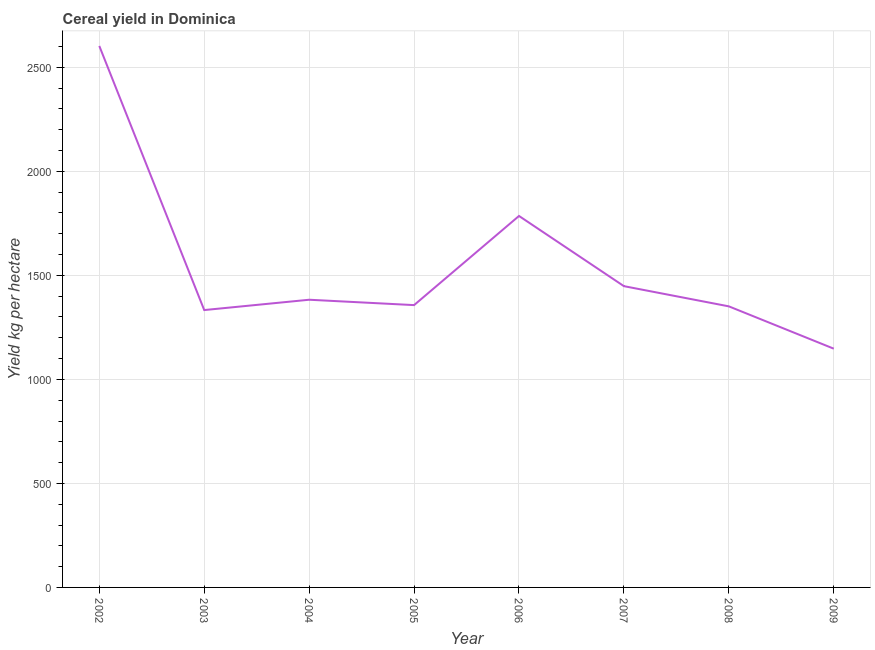What is the cereal yield in 2006?
Your answer should be compact. 1785.71. Across all years, what is the maximum cereal yield?
Ensure brevity in your answer.  2602.94. Across all years, what is the minimum cereal yield?
Keep it short and to the point. 1147.73. In which year was the cereal yield maximum?
Make the answer very short. 2002. In which year was the cereal yield minimum?
Make the answer very short. 2009. What is the sum of the cereal yield?
Provide a short and direct response. 1.24e+04. What is the difference between the cereal yield in 2005 and 2008?
Keep it short and to the point. 6. What is the average cereal yield per year?
Make the answer very short. 1551.16. What is the median cereal yield?
Your answer should be very brief. 1370.06. Do a majority of the years between 2006 and 2003 (inclusive) have cereal yield greater than 1500 kg per hectare?
Provide a short and direct response. Yes. What is the ratio of the cereal yield in 2006 to that in 2009?
Your answer should be very brief. 1.56. Is the difference between the cereal yield in 2004 and 2007 greater than the difference between any two years?
Ensure brevity in your answer.  No. What is the difference between the highest and the second highest cereal yield?
Your answer should be very brief. 817.23. What is the difference between the highest and the lowest cereal yield?
Offer a very short reply. 1455.21. Does the cereal yield monotonically increase over the years?
Keep it short and to the point. No. How many lines are there?
Your response must be concise. 1. What is the difference between two consecutive major ticks on the Y-axis?
Your answer should be very brief. 500. Are the values on the major ticks of Y-axis written in scientific E-notation?
Provide a short and direct response. No. Does the graph contain any zero values?
Give a very brief answer. No. What is the title of the graph?
Offer a terse response. Cereal yield in Dominica. What is the label or title of the X-axis?
Keep it short and to the point. Year. What is the label or title of the Y-axis?
Ensure brevity in your answer.  Yield kg per hectare. What is the Yield kg per hectare of 2002?
Make the answer very short. 2602.94. What is the Yield kg per hectare of 2003?
Offer a very short reply. 1333.33. What is the Yield kg per hectare in 2004?
Your answer should be very brief. 1382.98. What is the Yield kg per hectare of 2005?
Make the answer very short. 1357.14. What is the Yield kg per hectare in 2006?
Keep it short and to the point. 1785.71. What is the Yield kg per hectare in 2007?
Offer a terse response. 1448.28. What is the Yield kg per hectare of 2008?
Provide a short and direct response. 1351.14. What is the Yield kg per hectare in 2009?
Keep it short and to the point. 1147.73. What is the difference between the Yield kg per hectare in 2002 and 2003?
Give a very brief answer. 1269.61. What is the difference between the Yield kg per hectare in 2002 and 2004?
Keep it short and to the point. 1219.96. What is the difference between the Yield kg per hectare in 2002 and 2005?
Offer a terse response. 1245.8. What is the difference between the Yield kg per hectare in 2002 and 2006?
Your response must be concise. 817.23. What is the difference between the Yield kg per hectare in 2002 and 2007?
Your answer should be very brief. 1154.66. What is the difference between the Yield kg per hectare in 2002 and 2008?
Make the answer very short. 1251.8. What is the difference between the Yield kg per hectare in 2002 and 2009?
Ensure brevity in your answer.  1455.21. What is the difference between the Yield kg per hectare in 2003 and 2004?
Your response must be concise. -49.65. What is the difference between the Yield kg per hectare in 2003 and 2005?
Your answer should be very brief. -23.81. What is the difference between the Yield kg per hectare in 2003 and 2006?
Offer a very short reply. -452.38. What is the difference between the Yield kg per hectare in 2003 and 2007?
Offer a very short reply. -114.94. What is the difference between the Yield kg per hectare in 2003 and 2008?
Give a very brief answer. -17.81. What is the difference between the Yield kg per hectare in 2003 and 2009?
Make the answer very short. 185.61. What is the difference between the Yield kg per hectare in 2004 and 2005?
Your response must be concise. 25.84. What is the difference between the Yield kg per hectare in 2004 and 2006?
Provide a succinct answer. -402.74. What is the difference between the Yield kg per hectare in 2004 and 2007?
Your answer should be compact. -65.3. What is the difference between the Yield kg per hectare in 2004 and 2008?
Keep it short and to the point. 31.83. What is the difference between the Yield kg per hectare in 2004 and 2009?
Ensure brevity in your answer.  235.25. What is the difference between the Yield kg per hectare in 2005 and 2006?
Keep it short and to the point. -428.57. What is the difference between the Yield kg per hectare in 2005 and 2007?
Keep it short and to the point. -91.13. What is the difference between the Yield kg per hectare in 2005 and 2008?
Make the answer very short. 6. What is the difference between the Yield kg per hectare in 2005 and 2009?
Provide a succinct answer. 209.42. What is the difference between the Yield kg per hectare in 2006 and 2007?
Your answer should be very brief. 337.44. What is the difference between the Yield kg per hectare in 2006 and 2008?
Keep it short and to the point. 434.57. What is the difference between the Yield kg per hectare in 2006 and 2009?
Make the answer very short. 637.99. What is the difference between the Yield kg per hectare in 2007 and 2008?
Your answer should be very brief. 97.13. What is the difference between the Yield kg per hectare in 2007 and 2009?
Offer a terse response. 300.55. What is the difference between the Yield kg per hectare in 2008 and 2009?
Provide a short and direct response. 203.42. What is the ratio of the Yield kg per hectare in 2002 to that in 2003?
Provide a short and direct response. 1.95. What is the ratio of the Yield kg per hectare in 2002 to that in 2004?
Make the answer very short. 1.88. What is the ratio of the Yield kg per hectare in 2002 to that in 2005?
Keep it short and to the point. 1.92. What is the ratio of the Yield kg per hectare in 2002 to that in 2006?
Your answer should be compact. 1.46. What is the ratio of the Yield kg per hectare in 2002 to that in 2007?
Provide a short and direct response. 1.8. What is the ratio of the Yield kg per hectare in 2002 to that in 2008?
Ensure brevity in your answer.  1.93. What is the ratio of the Yield kg per hectare in 2002 to that in 2009?
Your response must be concise. 2.27. What is the ratio of the Yield kg per hectare in 2003 to that in 2006?
Offer a very short reply. 0.75. What is the ratio of the Yield kg per hectare in 2003 to that in 2007?
Offer a terse response. 0.92. What is the ratio of the Yield kg per hectare in 2003 to that in 2009?
Give a very brief answer. 1.16. What is the ratio of the Yield kg per hectare in 2004 to that in 2005?
Make the answer very short. 1.02. What is the ratio of the Yield kg per hectare in 2004 to that in 2006?
Keep it short and to the point. 0.77. What is the ratio of the Yield kg per hectare in 2004 to that in 2007?
Ensure brevity in your answer.  0.95. What is the ratio of the Yield kg per hectare in 2004 to that in 2009?
Provide a succinct answer. 1.21. What is the ratio of the Yield kg per hectare in 2005 to that in 2006?
Make the answer very short. 0.76. What is the ratio of the Yield kg per hectare in 2005 to that in 2007?
Keep it short and to the point. 0.94. What is the ratio of the Yield kg per hectare in 2005 to that in 2008?
Offer a very short reply. 1. What is the ratio of the Yield kg per hectare in 2005 to that in 2009?
Give a very brief answer. 1.18. What is the ratio of the Yield kg per hectare in 2006 to that in 2007?
Make the answer very short. 1.23. What is the ratio of the Yield kg per hectare in 2006 to that in 2008?
Keep it short and to the point. 1.32. What is the ratio of the Yield kg per hectare in 2006 to that in 2009?
Provide a short and direct response. 1.56. What is the ratio of the Yield kg per hectare in 2007 to that in 2008?
Your answer should be very brief. 1.07. What is the ratio of the Yield kg per hectare in 2007 to that in 2009?
Your answer should be compact. 1.26. What is the ratio of the Yield kg per hectare in 2008 to that in 2009?
Provide a succinct answer. 1.18. 